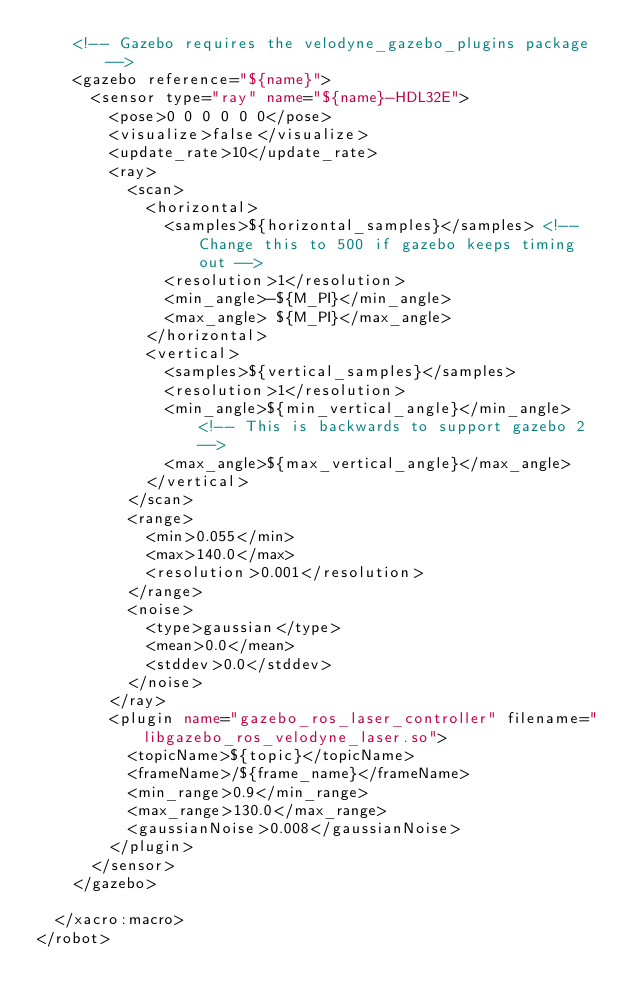Convert code to text. <code><loc_0><loc_0><loc_500><loc_500><_XML_>    <!-- Gazebo requires the velodyne_gazebo_plugins package -->
    <gazebo reference="${name}">
      <sensor type="ray" name="${name}-HDL32E">
        <pose>0 0 0 0 0 0</pose>
        <visualize>false</visualize>
        <update_rate>10</update_rate>
        <ray>
          <scan>
            <horizontal>
              <samples>${horizontal_samples}</samples> <!-- Change this to 500 if gazebo keeps timing out -->
              <resolution>1</resolution>
              <min_angle>-${M_PI}</min_angle>
              <max_angle> ${M_PI}</max_angle>
            </horizontal>
            <vertical>
              <samples>${vertical_samples}</samples>
              <resolution>1</resolution>
              <min_angle>${min_vertical_angle}</min_angle> <!-- This is backwards to support gazebo 2 -->
              <max_angle>${max_vertical_angle}</max_angle>
            </vertical>
          </scan>
          <range>
            <min>0.055</min>
            <max>140.0</max>
            <resolution>0.001</resolution>
          </range>
          <noise>
            <type>gaussian</type>
            <mean>0.0</mean>
            <stddev>0.0</stddev>
          </noise>
        </ray>
        <plugin name="gazebo_ros_laser_controller" filename="libgazebo_ros_velodyne_laser.so">
          <topicName>${topic}</topicName>
          <frameName>/${frame_name}</frameName>
          <min_range>0.9</min_range>
          <max_range>130.0</max_range>
          <gaussianNoise>0.008</gaussianNoise>
        </plugin>
      </sensor>
    </gazebo>

  </xacro:macro>
</robot>
</code> 